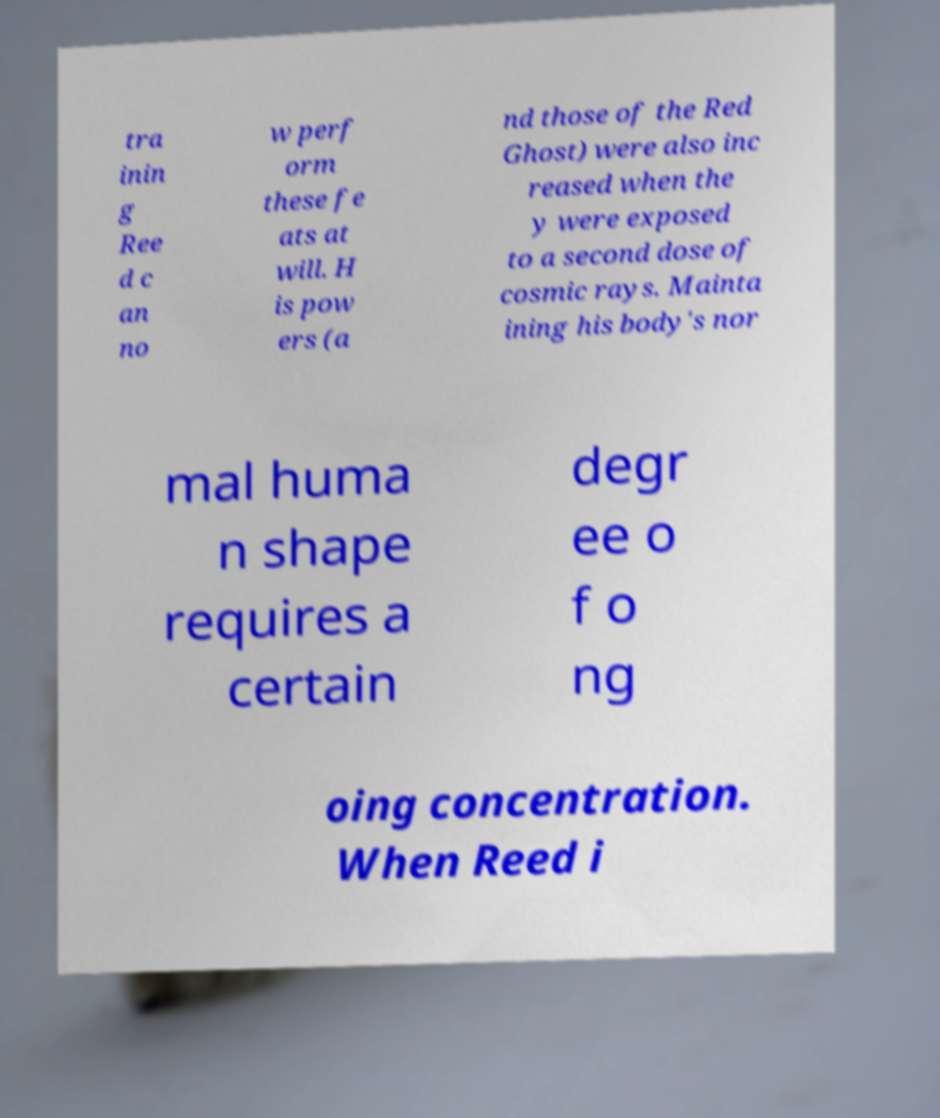Please read and relay the text visible in this image. What does it say? tra inin g Ree d c an no w perf orm these fe ats at will. H is pow ers (a nd those of the Red Ghost) were also inc reased when the y were exposed to a second dose of cosmic rays. Mainta ining his body's nor mal huma n shape requires a certain degr ee o f o ng oing concentration. When Reed i 